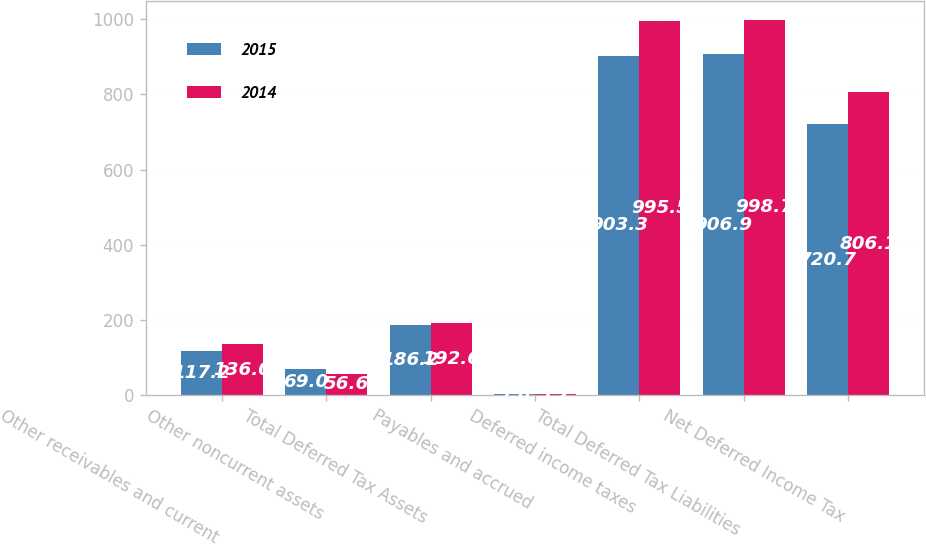Convert chart. <chart><loc_0><loc_0><loc_500><loc_500><stacked_bar_chart><ecel><fcel>Other receivables and current<fcel>Other noncurrent assets<fcel>Total Deferred Tax Assets<fcel>Payables and accrued<fcel>Deferred income taxes<fcel>Total Deferred Tax Liabilities<fcel>Net Deferred Income Tax<nl><fcel>2015<fcel>117.2<fcel>69<fcel>186.2<fcel>3.6<fcel>903.3<fcel>906.9<fcel>720.7<nl><fcel>2014<fcel>136<fcel>56.6<fcel>192.6<fcel>3.2<fcel>995.5<fcel>998.7<fcel>806.1<nl></chart> 